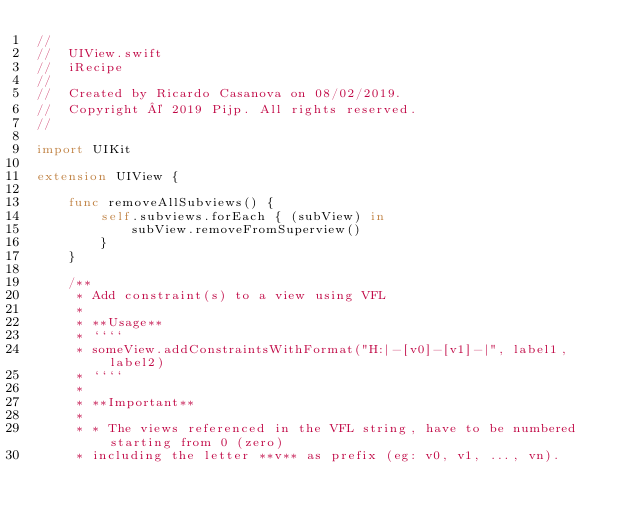Convert code to text. <code><loc_0><loc_0><loc_500><loc_500><_Swift_>//
//  UIView.swift
//  iRecipe
//
//  Created by Ricardo Casanova on 08/02/2019.
//  Copyright © 2019 Pijp. All rights reserved.
//

import UIKit

extension UIView {
    
    func removeAllSubviews() {
        self.subviews.forEach { (subView) in
            subView.removeFromSuperview()
        }
    }
    
    /**
     * Add constraint(s) to a view using VFL
     *
     * **Usage**
     * ````
     * someView.addConstraintsWithFormat("H:|-[v0]-[v1]-|", label1, label2)
     * ````
     *
     * **Important**
     *
     * * The views referenced in the VFL string, have to be numbered starting from 0 (zero)
     * including the letter **v** as prefix (eg: v0, v1, ..., vn).</code> 